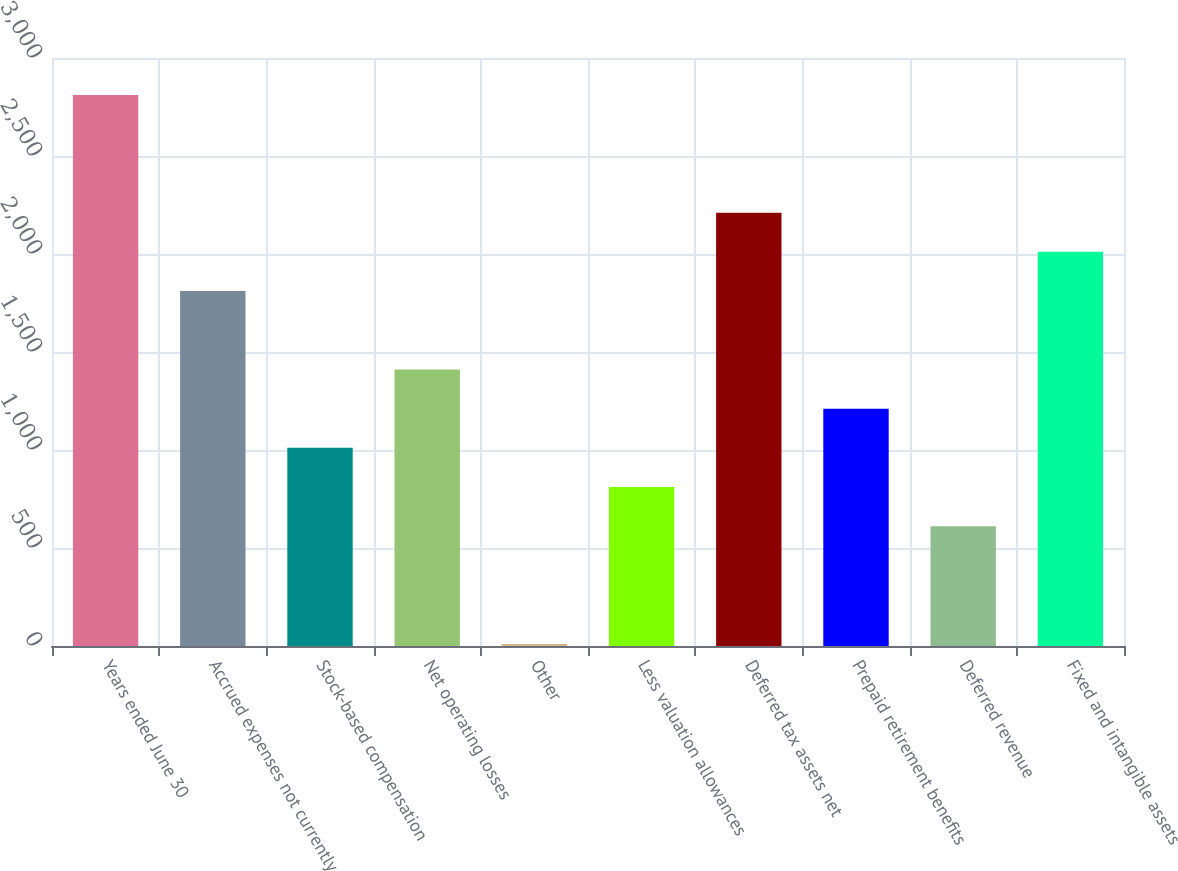Convert chart. <chart><loc_0><loc_0><loc_500><loc_500><bar_chart><fcel>Years ended June 30<fcel>Accrued expenses not currently<fcel>Stock-based compensation<fcel>Net operating losses<fcel>Other<fcel>Less valuation allowances<fcel>Deferred tax assets net<fcel>Prepaid retirement benefits<fcel>Deferred revenue<fcel>Fixed and intangible assets<nl><fcel>2811.08<fcel>1810.98<fcel>1010.9<fcel>1410.94<fcel>10.8<fcel>810.88<fcel>2211.02<fcel>1210.92<fcel>610.86<fcel>2011<nl></chart> 